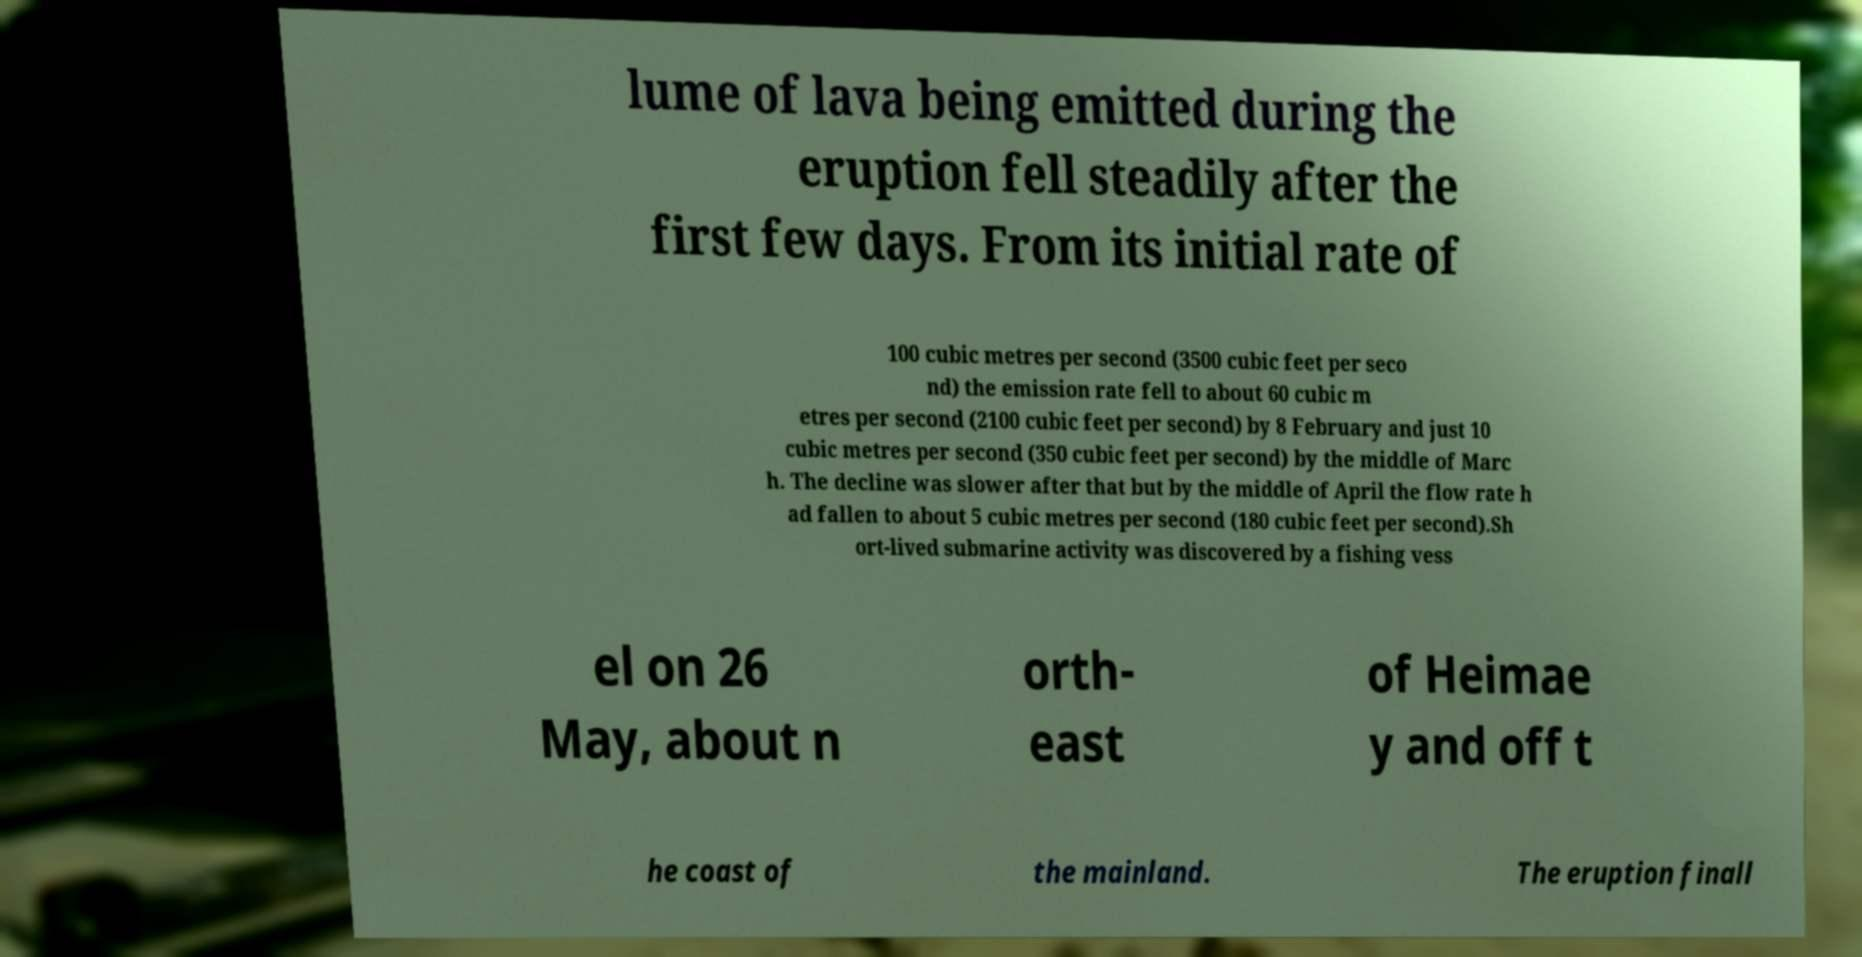I need the written content from this picture converted into text. Can you do that? lume of lava being emitted during the eruption fell steadily after the first few days. From its initial rate of 100 cubic metres per second (3500 cubic feet per seco nd) the emission rate fell to about 60 cubic m etres per second (2100 cubic feet per second) by 8 February and just 10 cubic metres per second (350 cubic feet per second) by the middle of Marc h. The decline was slower after that but by the middle of April the flow rate h ad fallen to about 5 cubic metres per second (180 cubic feet per second).Sh ort-lived submarine activity was discovered by a fishing vess el on 26 May, about n orth- east of Heimae y and off t he coast of the mainland. The eruption finall 